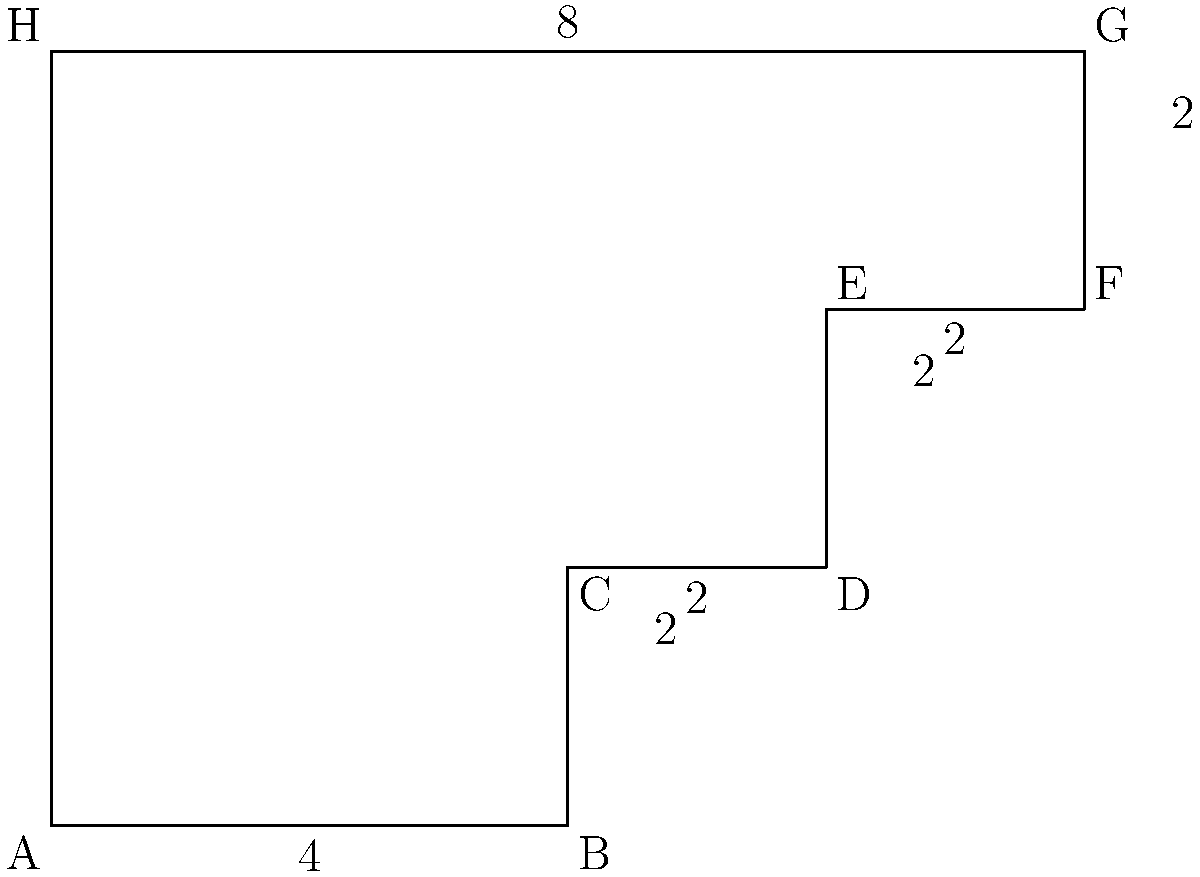The stepped polygon above represents the varying levels of labor law restrictions across different industries in a country. Each step corresponds to a specific industry, and the height of each step indicates the level of restrictions. If each unit on the graph represents 10 labor law provisions, calculate the perimeter of the polygon to determine the total number of labor law provisions across all industries. To calculate the perimeter of the stepped polygon, we need to sum up the lengths of all sides:

1. Bottom side: $4 \times 10 = 40$ provisions
2. First vertical step: $2 \times 10 = 20$ provisions
3. First horizontal step: $2 \times 10 = 20$ provisions
4. Second vertical step: $2 \times 10 = 20$ provisions
5. Second horizontal step: $2 \times 10 = 20$ provisions
6. Third vertical step: $2 \times 10 = 20$ provisions
7. Top side: $8 \times 10 = 80$ provisions
8. Left side: $6 \times 10 = 60$ provisions

Total perimeter: $40 + 20 + 20 + 20 + 20 + 20 + 80 + 60 = 280$

Therefore, the total number of labor law provisions across all industries is 280.
Answer: 280 provisions 